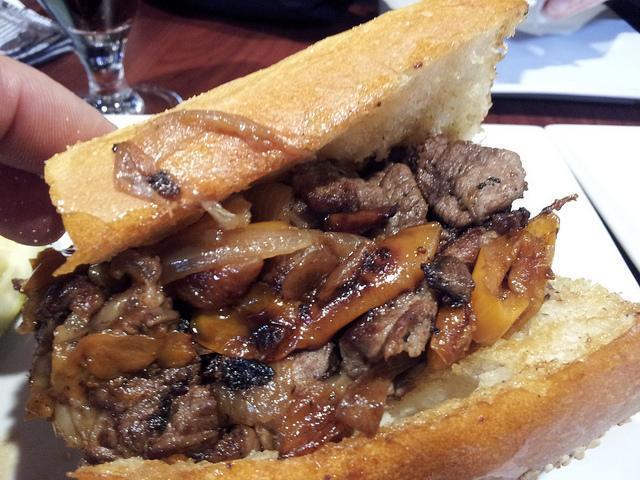Is the statement "The person is touching the sandwich." accurate regarding the image?
Answer yes or no. Yes. 